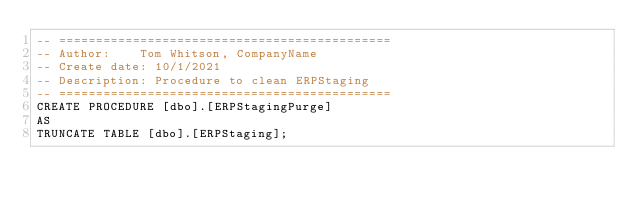<code> <loc_0><loc_0><loc_500><loc_500><_SQL_>-- =============================================
-- Author:		Tom Whitson, CompanyName
-- Create date: 10/1/2021
-- Description:	Procedure to clean ERPStaging
-- =============================================
CREATE PROCEDURE [dbo].[ERPStagingPurge]
AS
TRUNCATE TABLE [dbo].[ERPStaging];</code> 